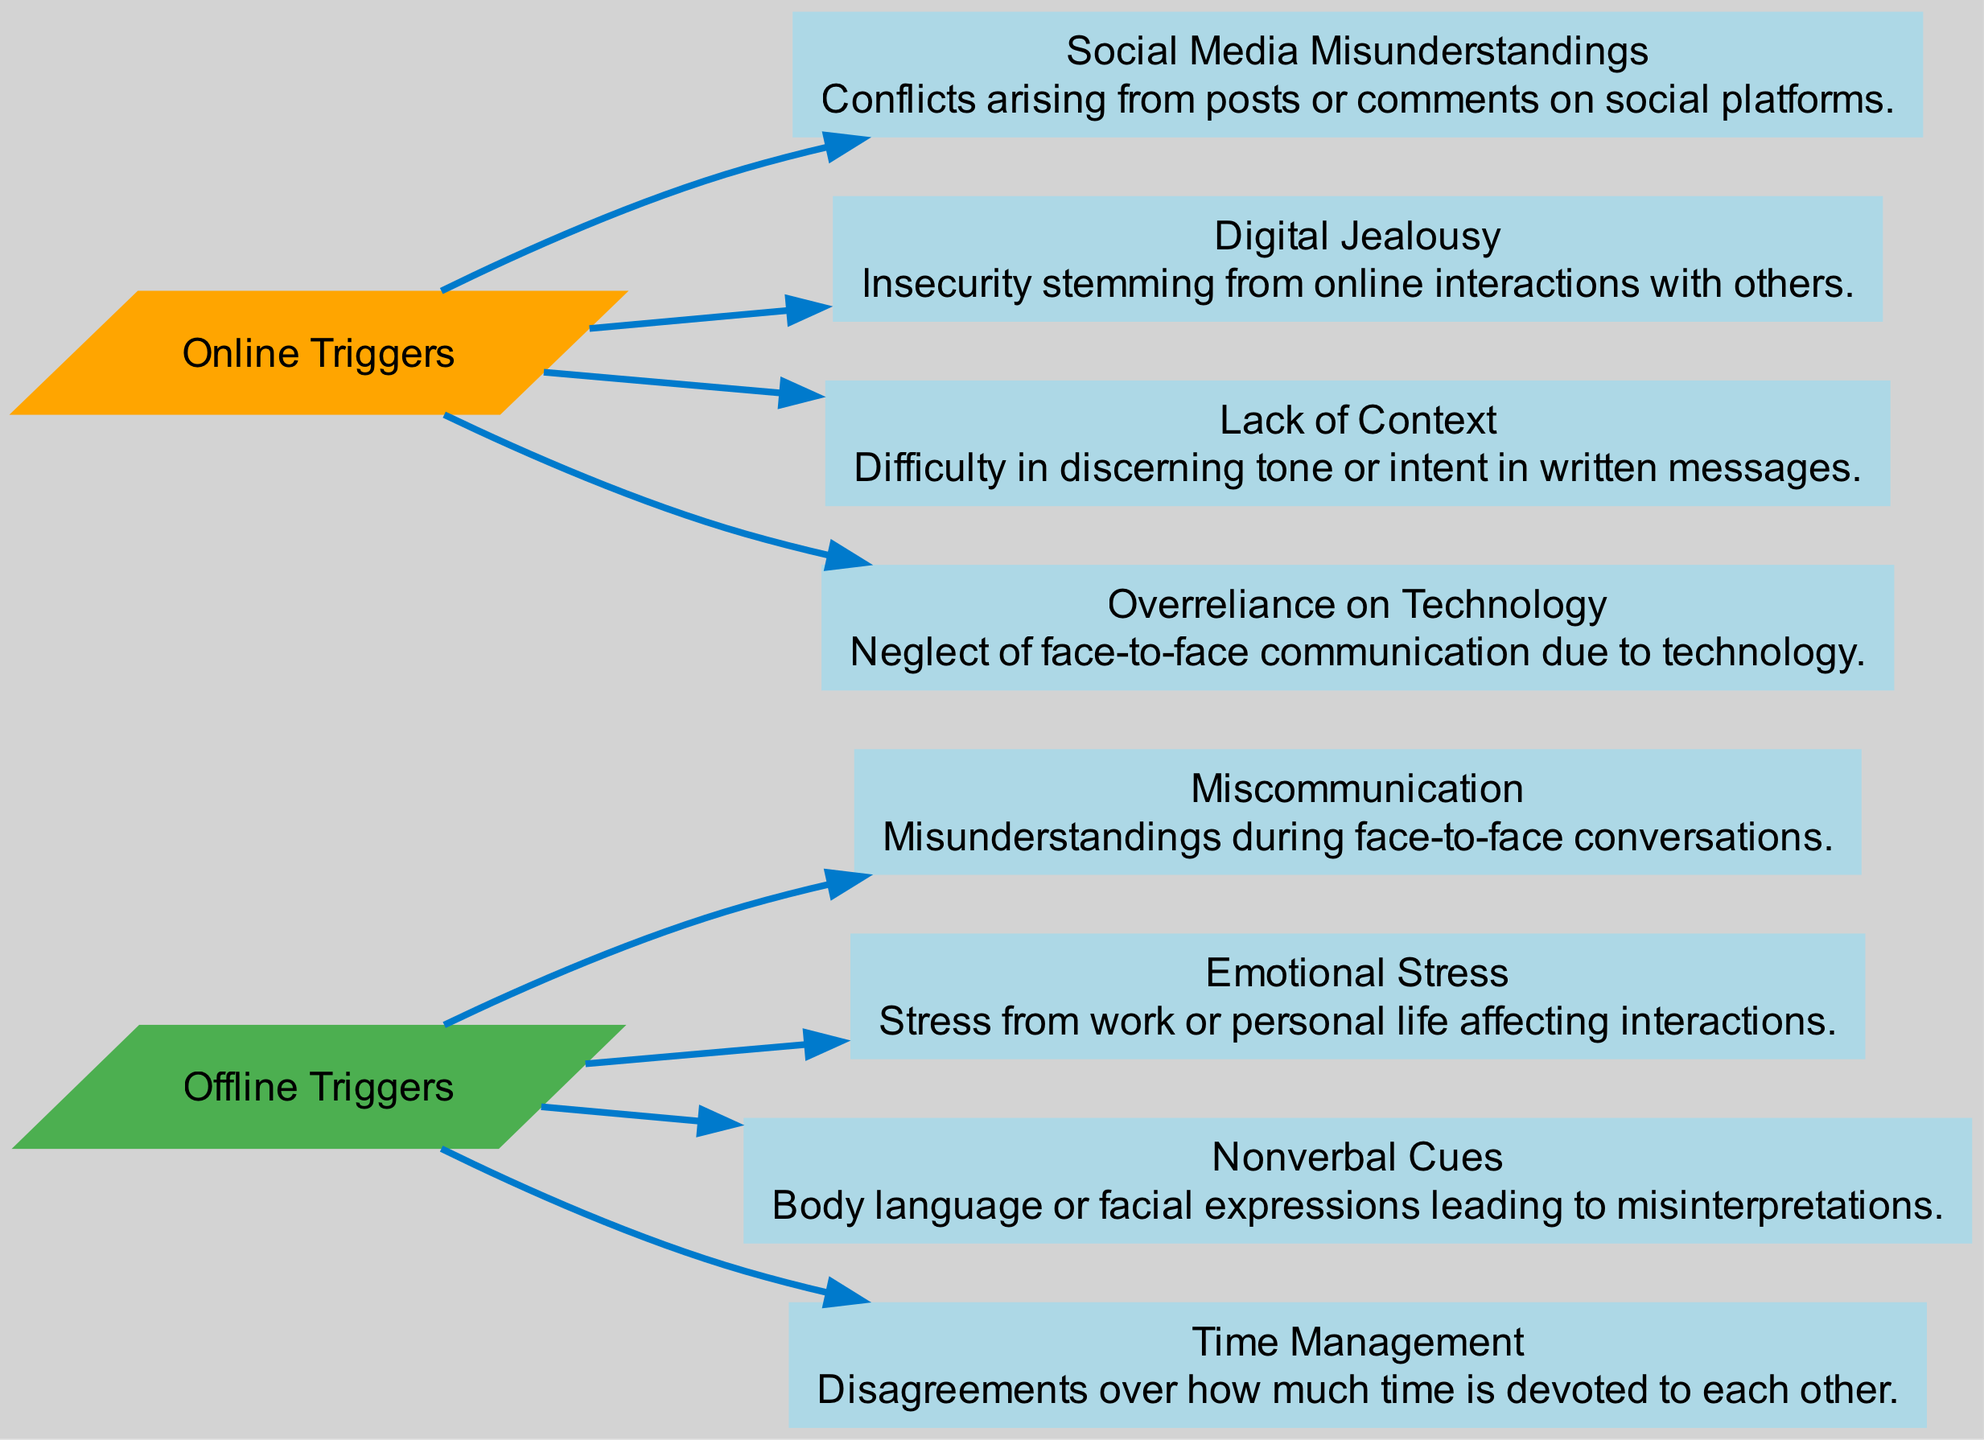What are the offline triggers listed in the diagram? The offline triggers are nodes branching from the "Offline Triggers" node. They include Miscommunication, Emotional Stress, Nonverbal Cues, and Time Management. These specific labels directly reflect the information provided in the diagram.
Answer: Miscommunication, Emotional Stress, Nonverbal Cues, Time Management How many online triggers are shown in the diagram? The online triggers are nodes stemming from the "Online Triggers" node. There are four listed: Social Media Misunderstandings, Digital Jealousy, Lack of Context, and Overreliance on Technology. Counting these nodes gives a total of four.
Answer: 4 What is the relationship between Nonverbal Cues and Offline Triggers? The Nonverbal Cues node is directly connected to the "Offline Triggers" node, indicating that it is categorized as one of the sources of conflict that arises offline. This relationship is visually represented as a direct edge from the Offline Triggers to Nonverbal Cues.
Answer: Nonverbal Cues is an offline trigger Which online trigger is related to online interactions with others? The online trigger that relates to online interactions is Digital Jealousy. This node highlights the conflict stemming from insecurity due to those interactions specifically, as described in its label in the diagram.
Answer: Digital Jealousy What is the main category for Emotional Stress in the diagram? Emotional Stress is linked to the "Offline Triggers" node, meaning it falls under the main category of conflicts that arise from in-person interactions rather than online. This categorization is explicitly represented in the visual structure of the diagram.
Answer: Offline Triggers Which trigger has a description involving face-to-face communication neglect? The trigger that mentions the neglect of face-to-face communication is Overreliance on Technology. Its description identifies the issue of tech use taking precedence over direct communication, which is clearly indicated in the diagram.
Answer: Overreliance on Technology What is the primary difference between Offline and Online triggers shown in the diagram? The primary difference is that Offline triggers stem from direct human interactions, such as misunderstandings and stress, while Online triggers arise from technology-mediated contexts like social media misunderstandings. This distinction is evident in the way each category is organized and labeled.
Answer: Nature of interaction How many edges connect from Offline Triggers to its triggers? Each trigger under "Offline Triggers" has a direct edge connecting it to that main category. Since there are four offline triggers: Miscommunication, Emotional Stress, Nonverbal Cues, and Time Management, this gives a total of four edges connecting to the Offline Triggers node.
Answer: 4 What does Lack of Context refer to in the context of online triggers? Lack of Context refers to the difficulty people experience in understanding the tone or intent behind written messages in digital interactions. This interpretation is drawn from its description, which clarifies the nature of the conflict stemming from online communication methods.
Answer: Difficulty in discerning tone or intent 